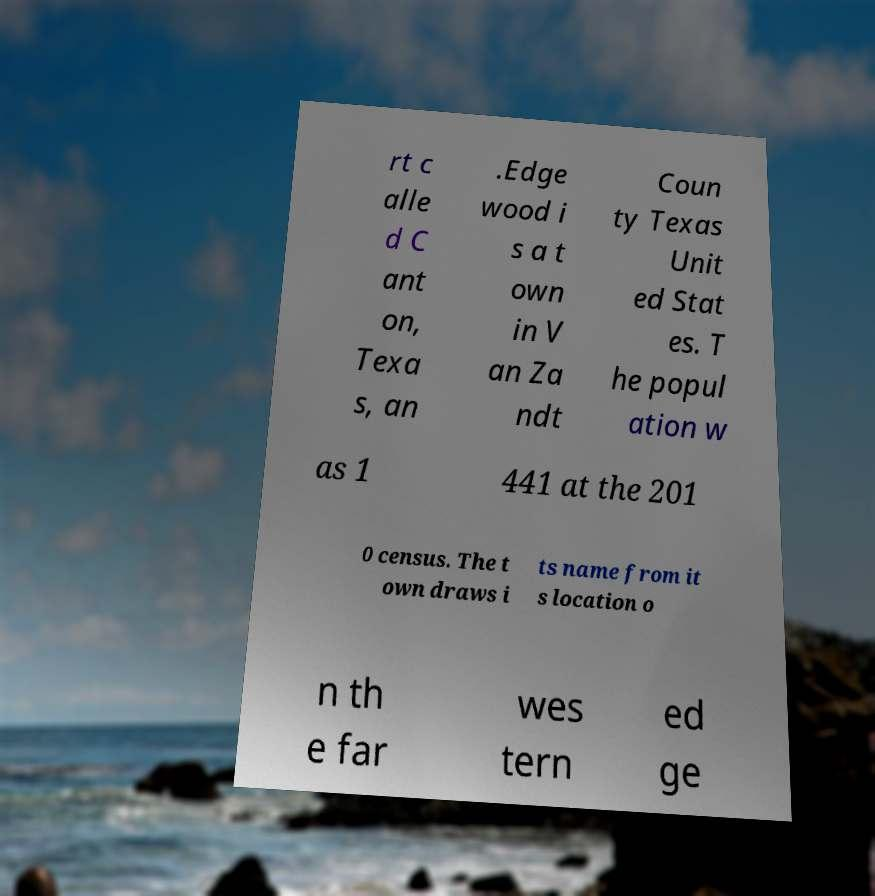Could you extract and type out the text from this image? rt c alle d C ant on, Texa s, an .Edge wood i s a t own in V an Za ndt Coun ty Texas Unit ed Stat es. T he popul ation w as 1 441 at the 201 0 census. The t own draws i ts name from it s location o n th e far wes tern ed ge 